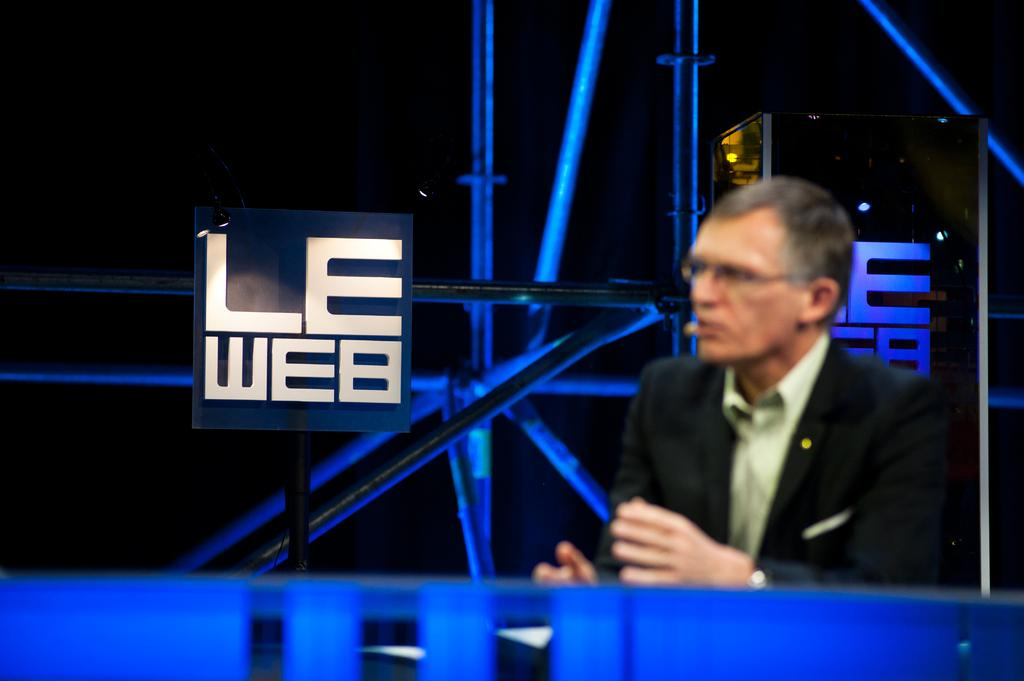<image>
Offer a succinct explanation of the picture presented. Man speaking on a show that has the letters saying LEWEB. 